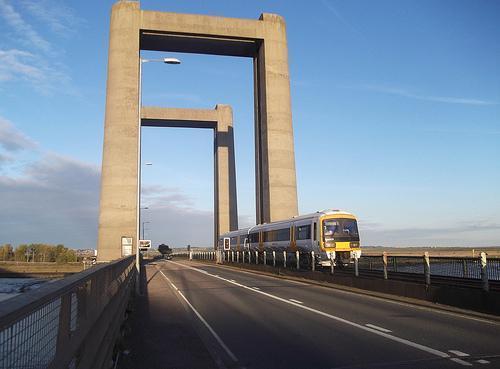How many trains are visible?
Give a very brief answer. 1. 